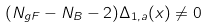<formula> <loc_0><loc_0><loc_500><loc_500>( N _ { g F } - N _ { B } - 2 ) \Delta _ { 1 , a } ( x ) \neq 0</formula> 